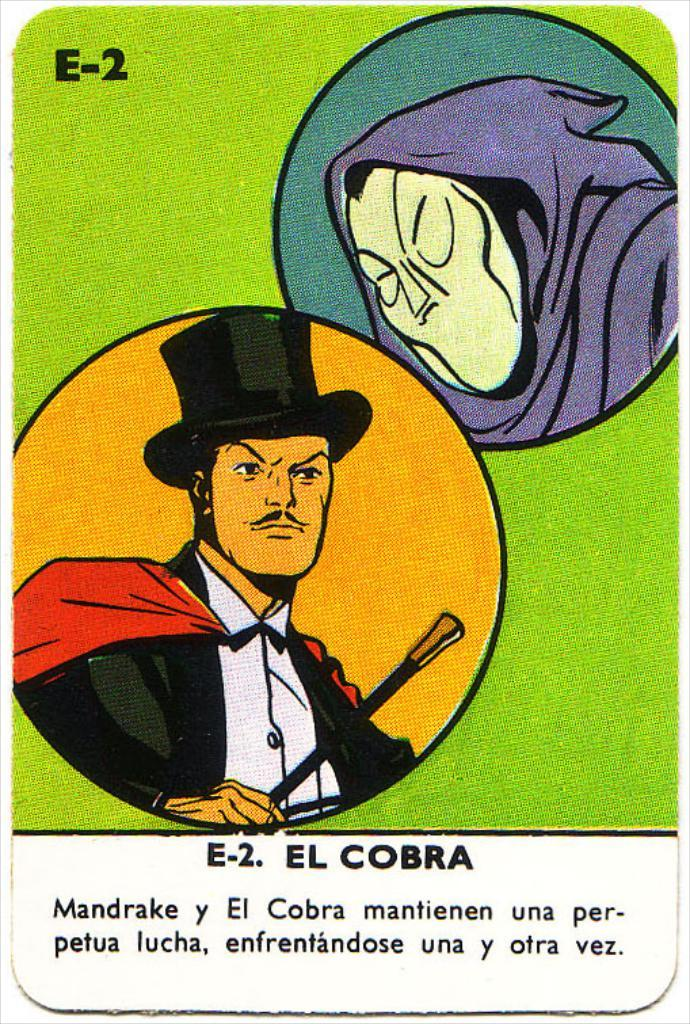What is the main subject of the image? The main subject of the image is a poster. What type of images are on the poster? The poster contains cartoon images. Is there any text on the poster? Yes, there is text at the bottom of the image. How many fish can be seen swimming in the image? There are no fish present in the image; it features a poster with cartoon images. What type of flock is visible in the image? There is no flock present in the image; it features a poster with cartoon images and text. 